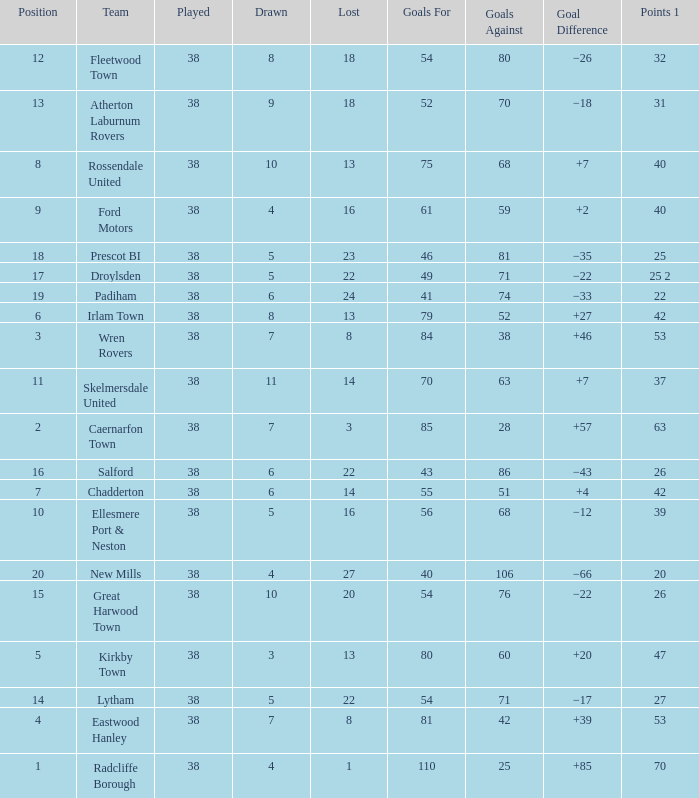Which Played has a Drawn of 4, and a Position of 9, and Goals Against larger than 59? None. 